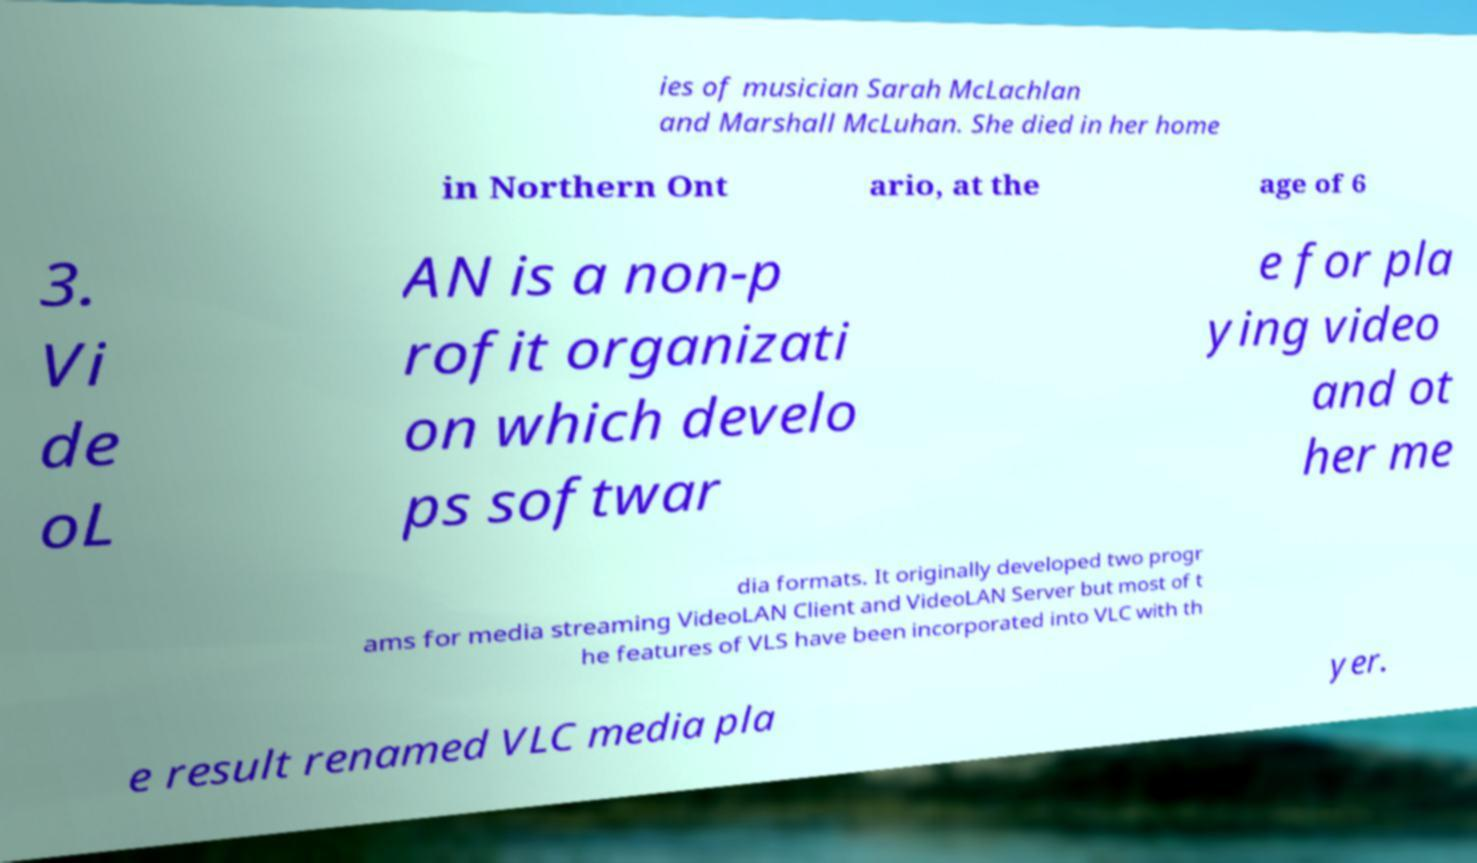For documentation purposes, I need the text within this image transcribed. Could you provide that? ies of musician Sarah McLachlan and Marshall McLuhan. She died in her home in Northern Ont ario, at the age of 6 3. Vi de oL AN is a non-p rofit organizati on which develo ps softwar e for pla ying video and ot her me dia formats. It originally developed two progr ams for media streaming VideoLAN Client and VideoLAN Server but most of t he features of VLS have been incorporated into VLC with th e result renamed VLC media pla yer. 